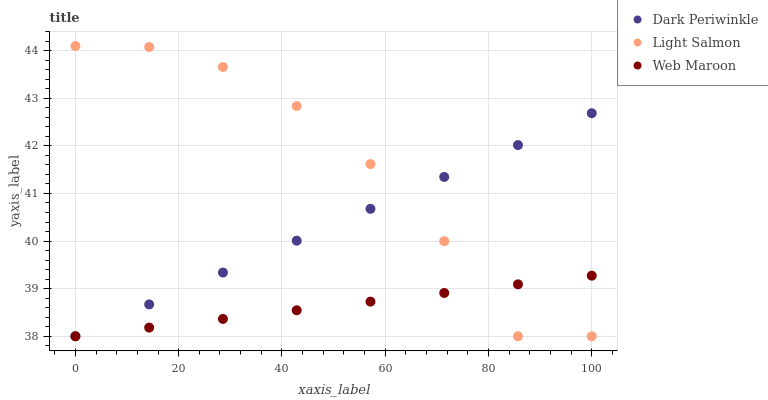Does Web Maroon have the minimum area under the curve?
Answer yes or no. Yes. Does Light Salmon have the maximum area under the curve?
Answer yes or no. Yes. Does Dark Periwinkle have the minimum area under the curve?
Answer yes or no. No. Does Dark Periwinkle have the maximum area under the curve?
Answer yes or no. No. Is Web Maroon the smoothest?
Answer yes or no. Yes. Is Light Salmon the roughest?
Answer yes or no. Yes. Is Dark Periwinkle the smoothest?
Answer yes or no. No. Is Dark Periwinkle the roughest?
Answer yes or no. No. Does Light Salmon have the lowest value?
Answer yes or no. Yes. Does Light Salmon have the highest value?
Answer yes or no. Yes. Does Dark Periwinkle have the highest value?
Answer yes or no. No. Does Light Salmon intersect Web Maroon?
Answer yes or no. Yes. Is Light Salmon less than Web Maroon?
Answer yes or no. No. Is Light Salmon greater than Web Maroon?
Answer yes or no. No. 